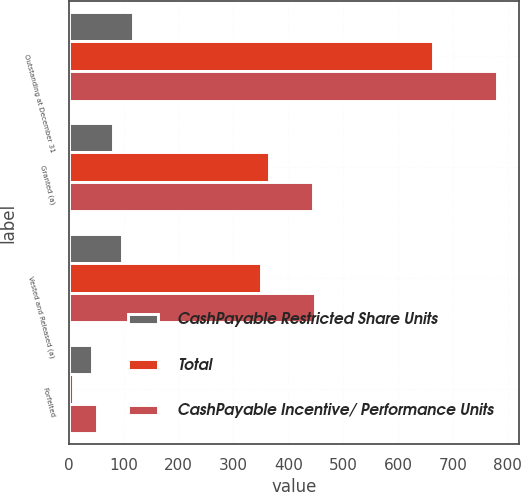Convert chart. <chart><loc_0><loc_0><loc_500><loc_500><stacked_bar_chart><ecel><fcel>Outstanding at December 31<fcel>Granted (a)<fcel>Vested and Released (a)<fcel>Forfeited<nl><fcel>CashPayable Restricted Share Units<fcel>117<fcel>81<fcel>98<fcel>43<nl><fcel>Total<fcel>664<fcel>364<fcel>350<fcel>8<nl><fcel>CashPayable Incentive/ Performance Units<fcel>781<fcel>445<fcel>448<fcel>51<nl></chart> 